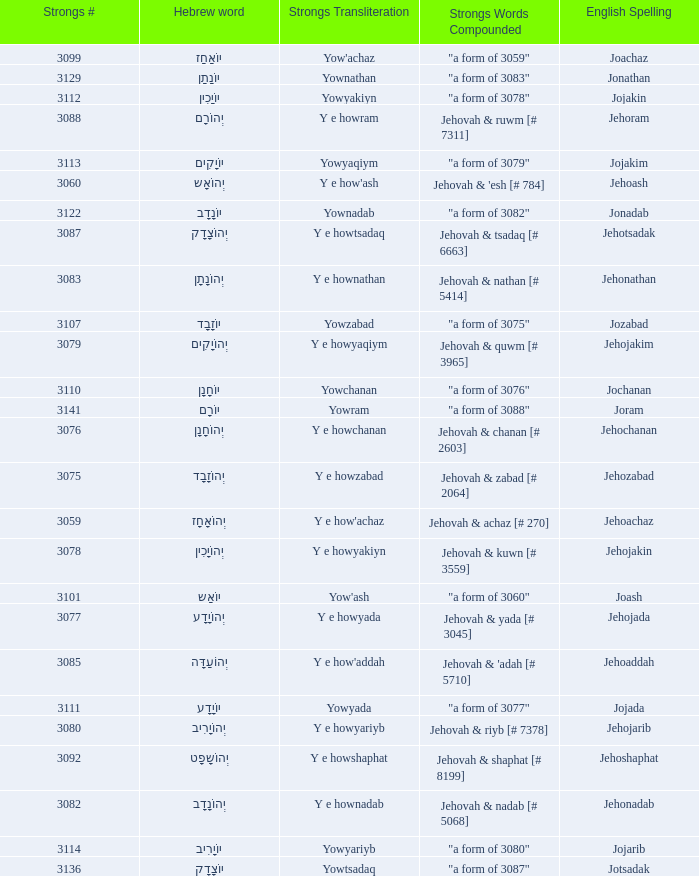What are the forceful words joined when the strongs transliteration is yowyariyb? "a form of 3080". 